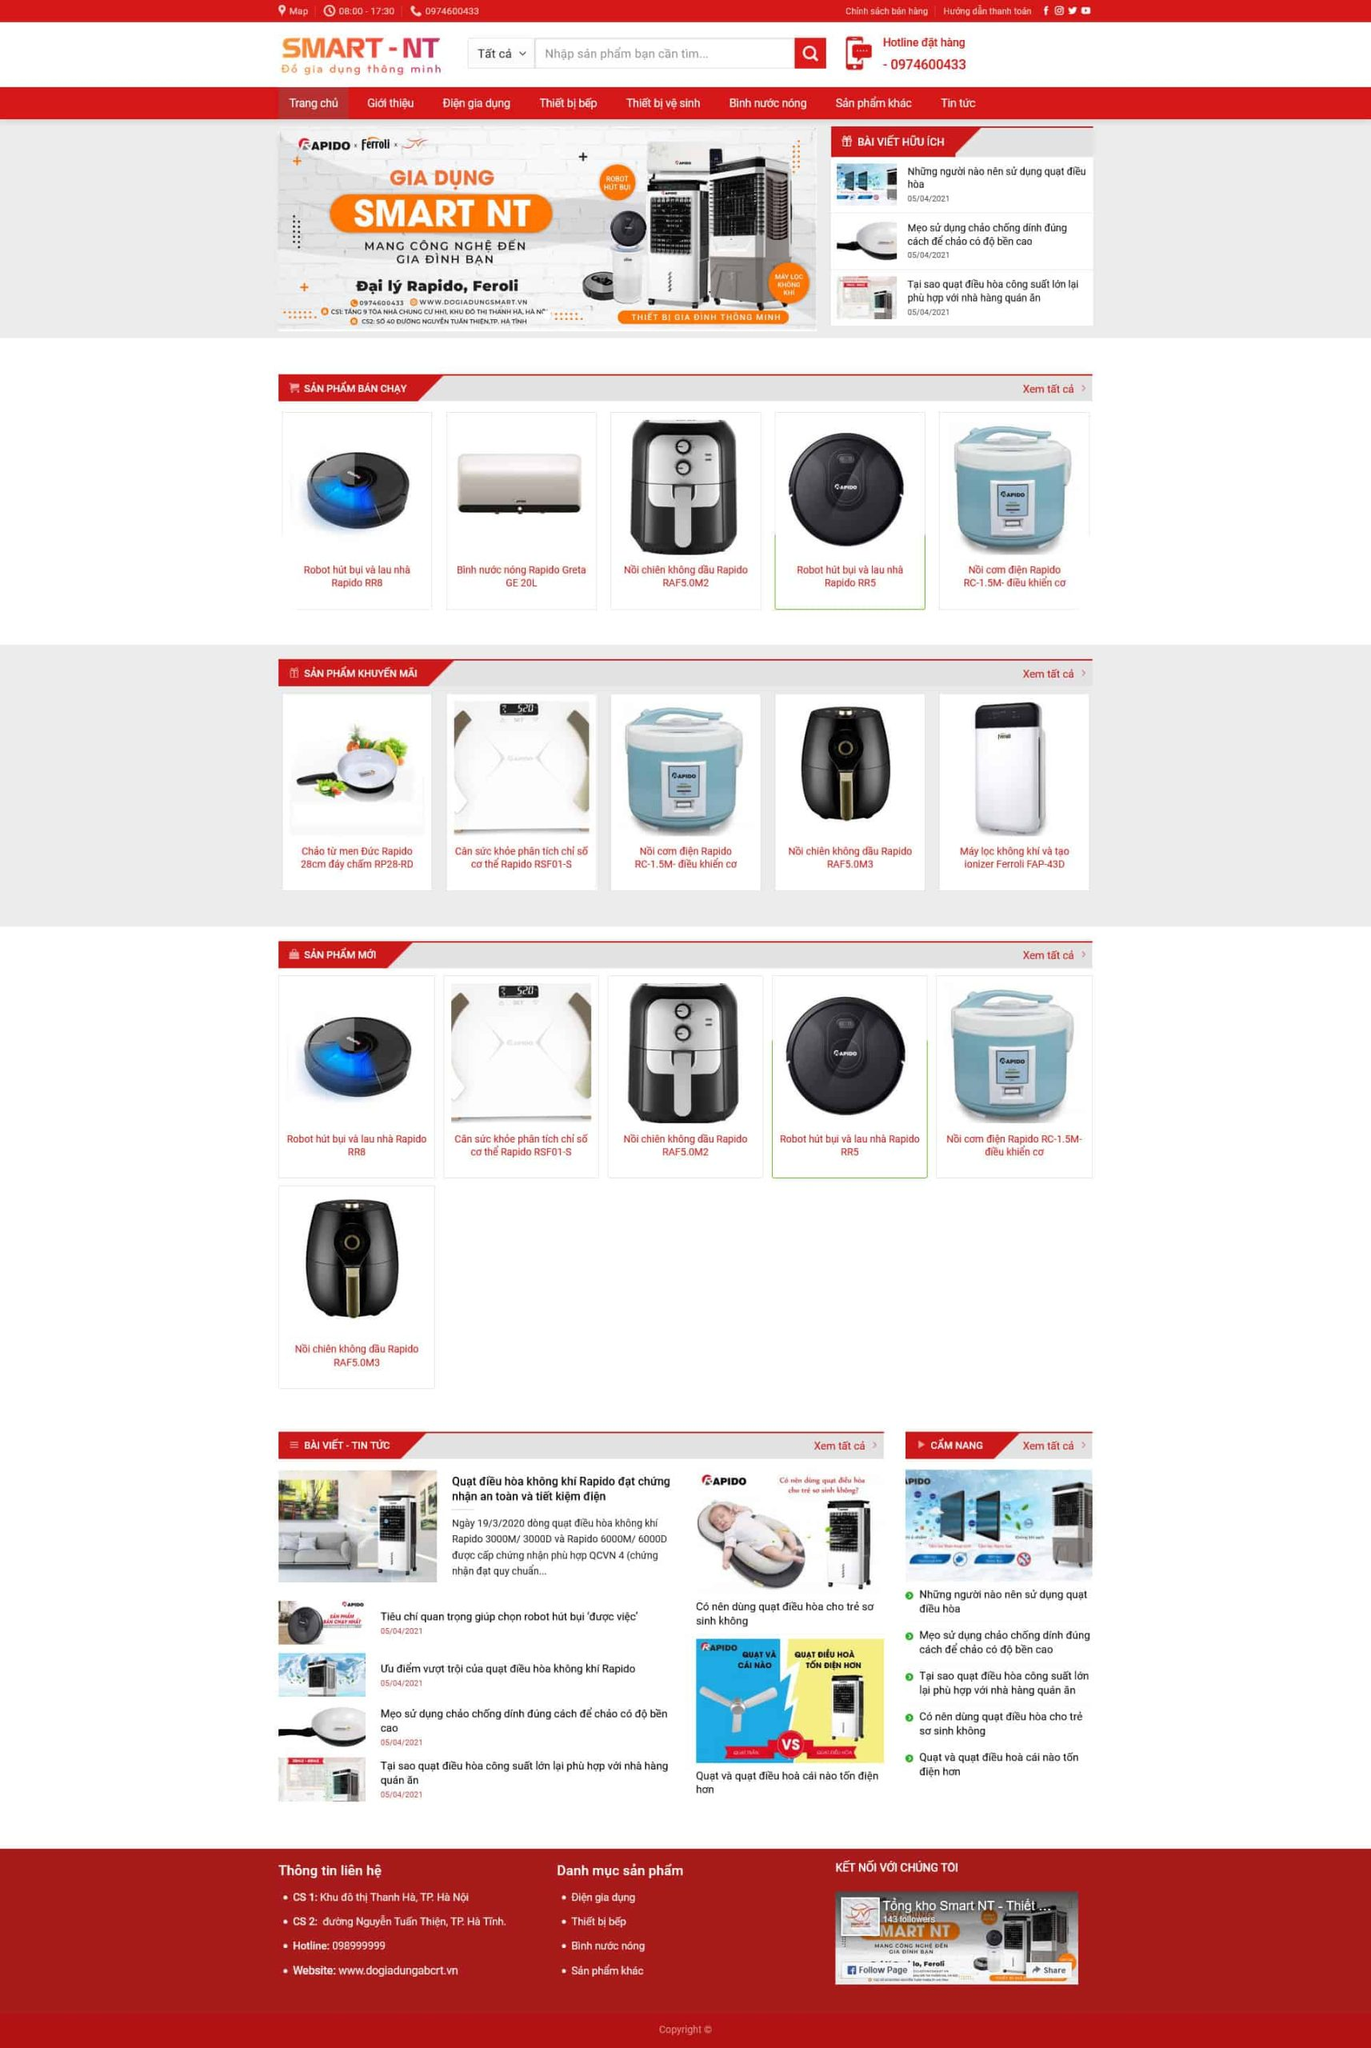Liệt kê 5 ngành nghề, lĩnh vực phù hợp với website này, phân cách các màu sắc bằng dấu phẩy. Chỉ trả về kết quả, phân cách bằng dấy phẩy
 Gia dụng,Thiết bị nhà bếp,Thiết bị vệ sinh,Bình nước nóng,Điện máy 